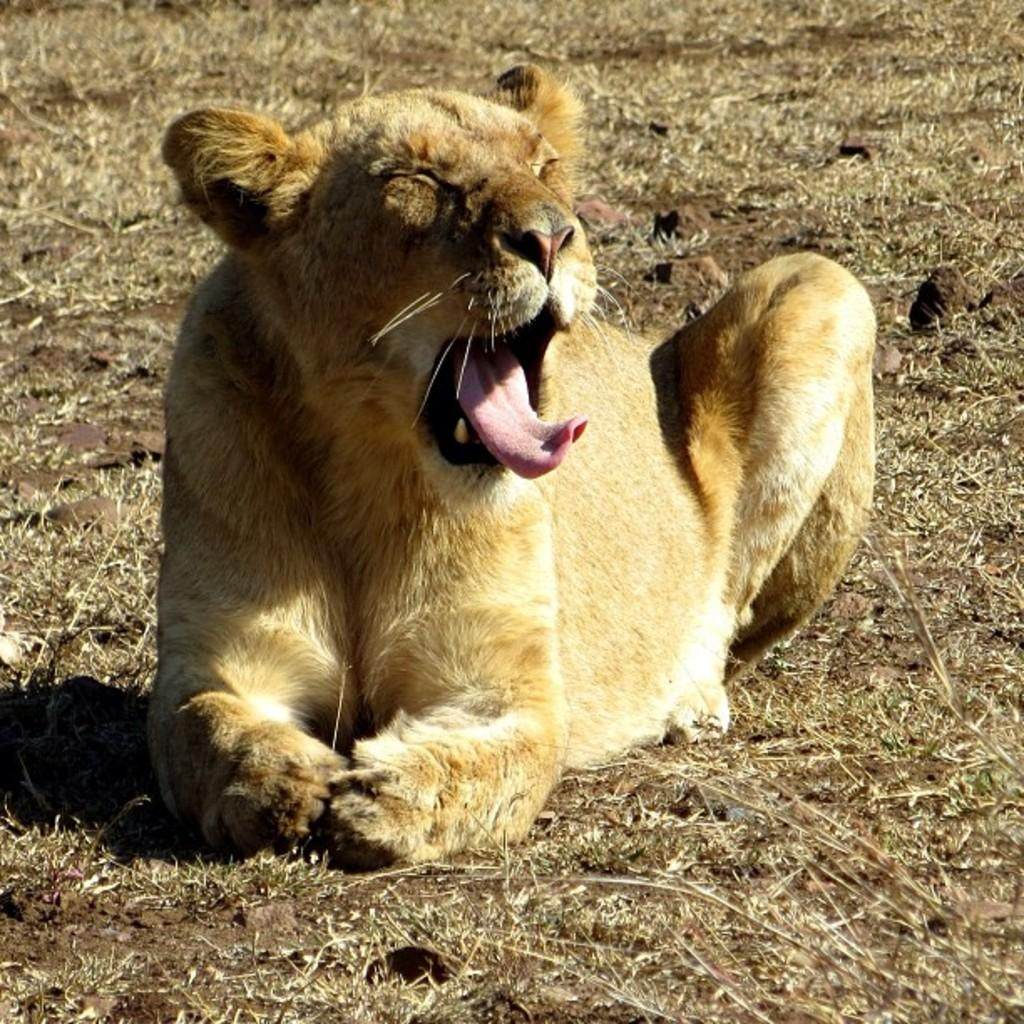What animal is the main subject of the image? There is a lioness in the image. What is the lioness doing in the image? The lioness is sitting on the ground. What type of surface is the lioness sitting on? The ground is covered with grass. Who is the owner of the lioness in the image? There is no indication in the image that the lioness has an owner. How many sisters does the lioness have in the image? There is only one lioness present in the image, so it cannot be determined if she has any sisters. 